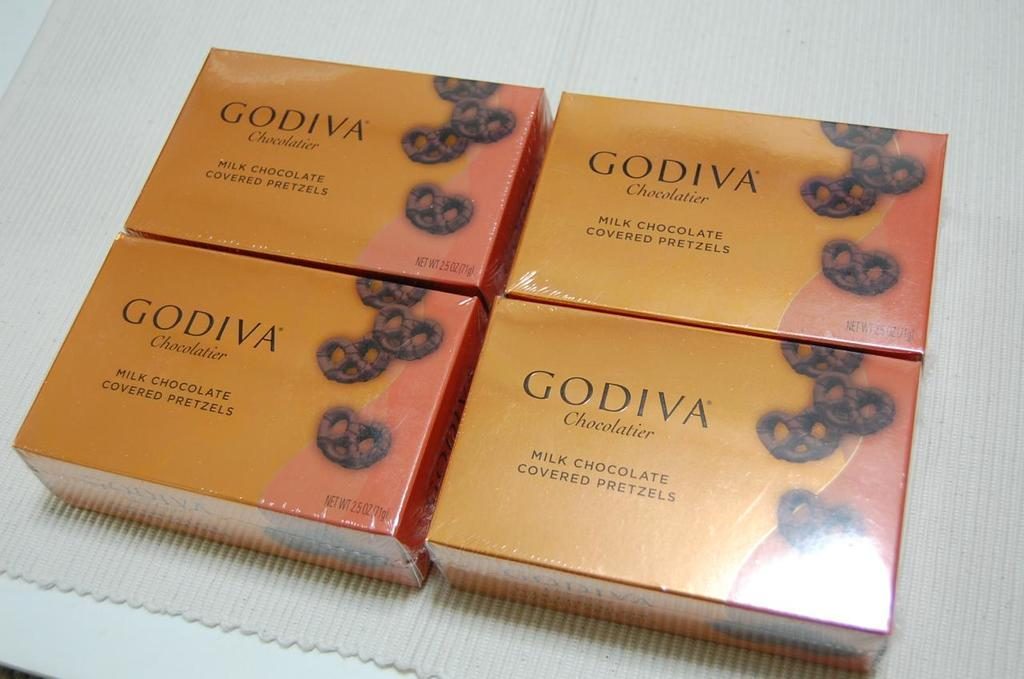<image>
Write a terse but informative summary of the picture. Four boxes of Godiva milk chocolate covered pretzels are displayed. 